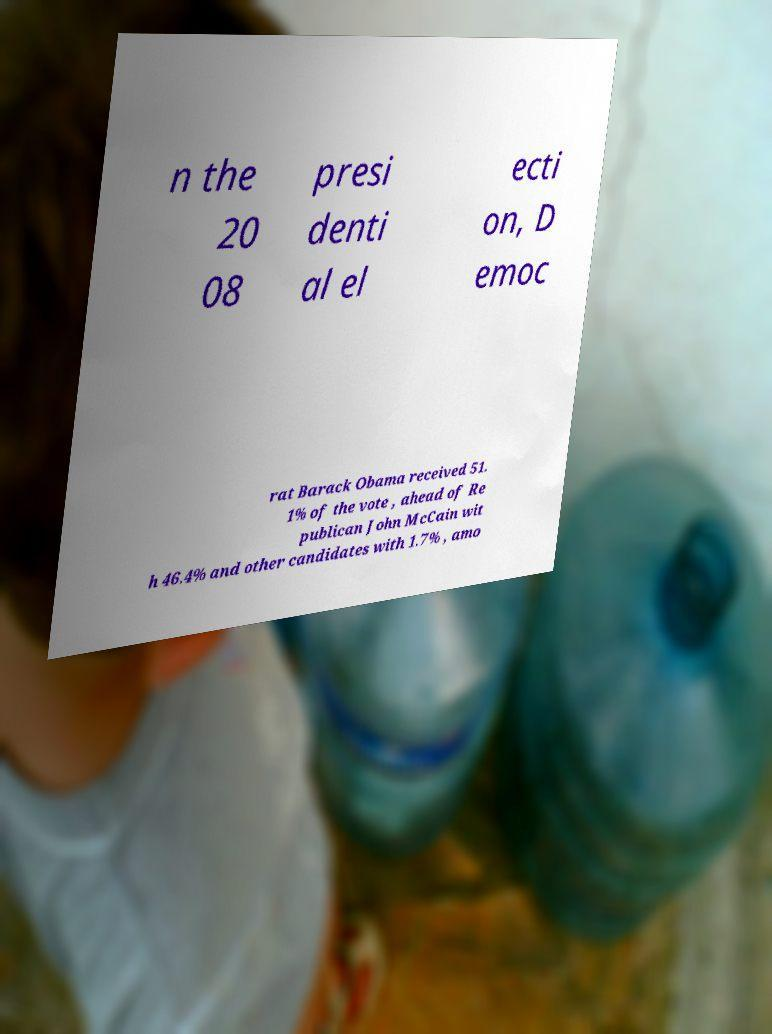There's text embedded in this image that I need extracted. Can you transcribe it verbatim? n the 20 08 presi denti al el ecti on, D emoc rat Barack Obama received 51. 1% of the vote , ahead of Re publican John McCain wit h 46.4% and other candidates with 1.7% , amo 